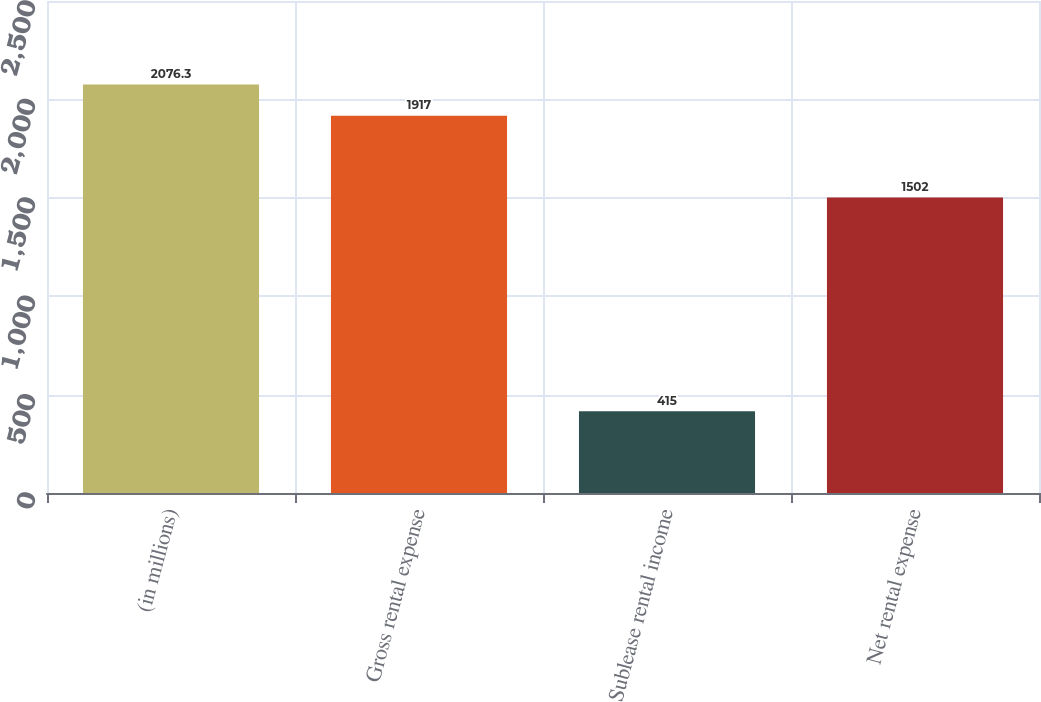Convert chart. <chart><loc_0><loc_0><loc_500><loc_500><bar_chart><fcel>(in millions)<fcel>Gross rental expense<fcel>Sublease rental income<fcel>Net rental expense<nl><fcel>2076.3<fcel>1917<fcel>415<fcel>1502<nl></chart> 